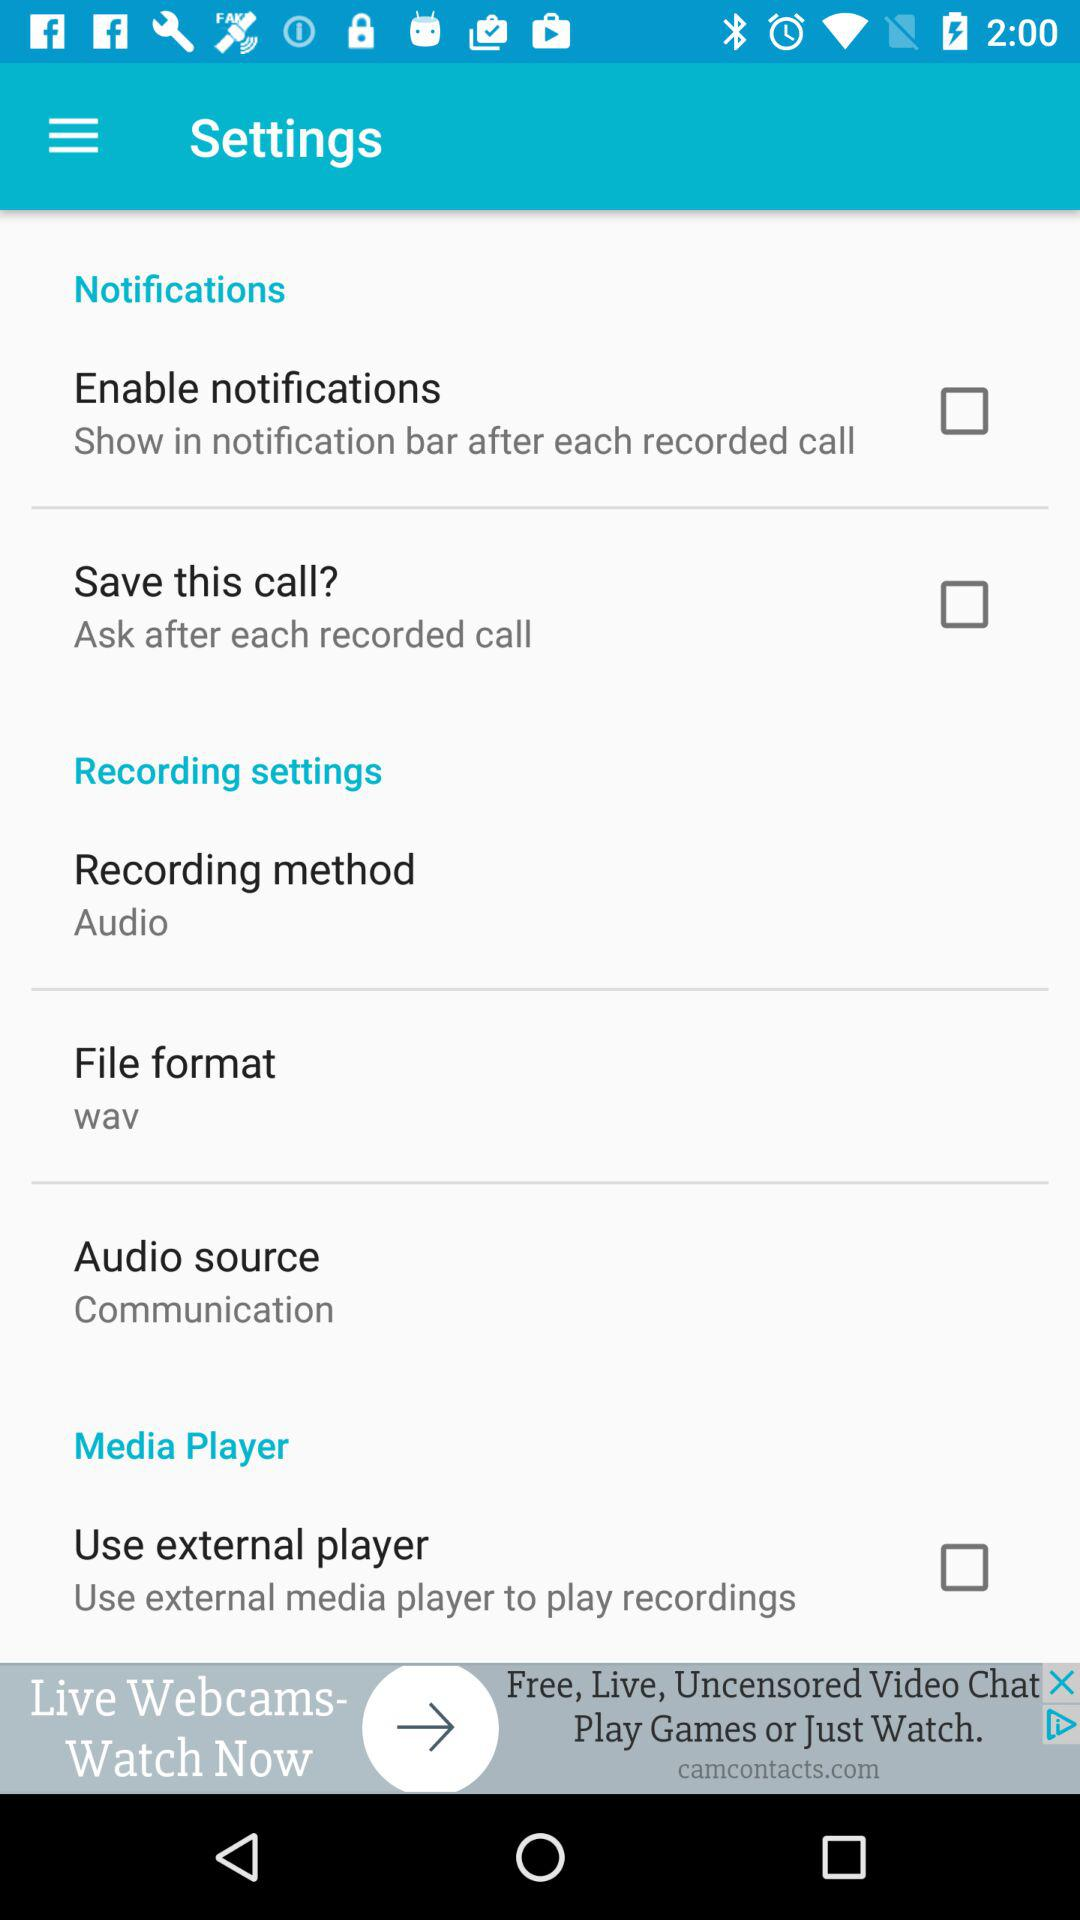What are the available options in the media player? The available option in the media player is "Use external player". 